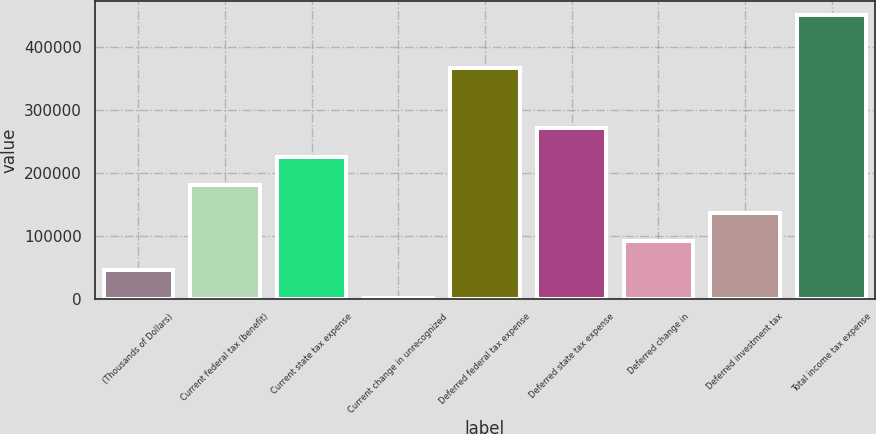<chart> <loc_0><loc_0><loc_500><loc_500><bar_chart><fcel>(Thousands of Dollars)<fcel>Current federal tax (benefit)<fcel>Current state tax expense<fcel>Current change in unrecognized<fcel>Deferred federal tax expense<fcel>Deferred state tax expense<fcel>Deferred change in<fcel>Deferred investment tax<fcel>Total income tax expense<nl><fcel>46553.9<fcel>181104<fcel>225954<fcel>1704<fcel>366409<fcel>270803<fcel>91403.8<fcel>136254<fcel>450203<nl></chart> 